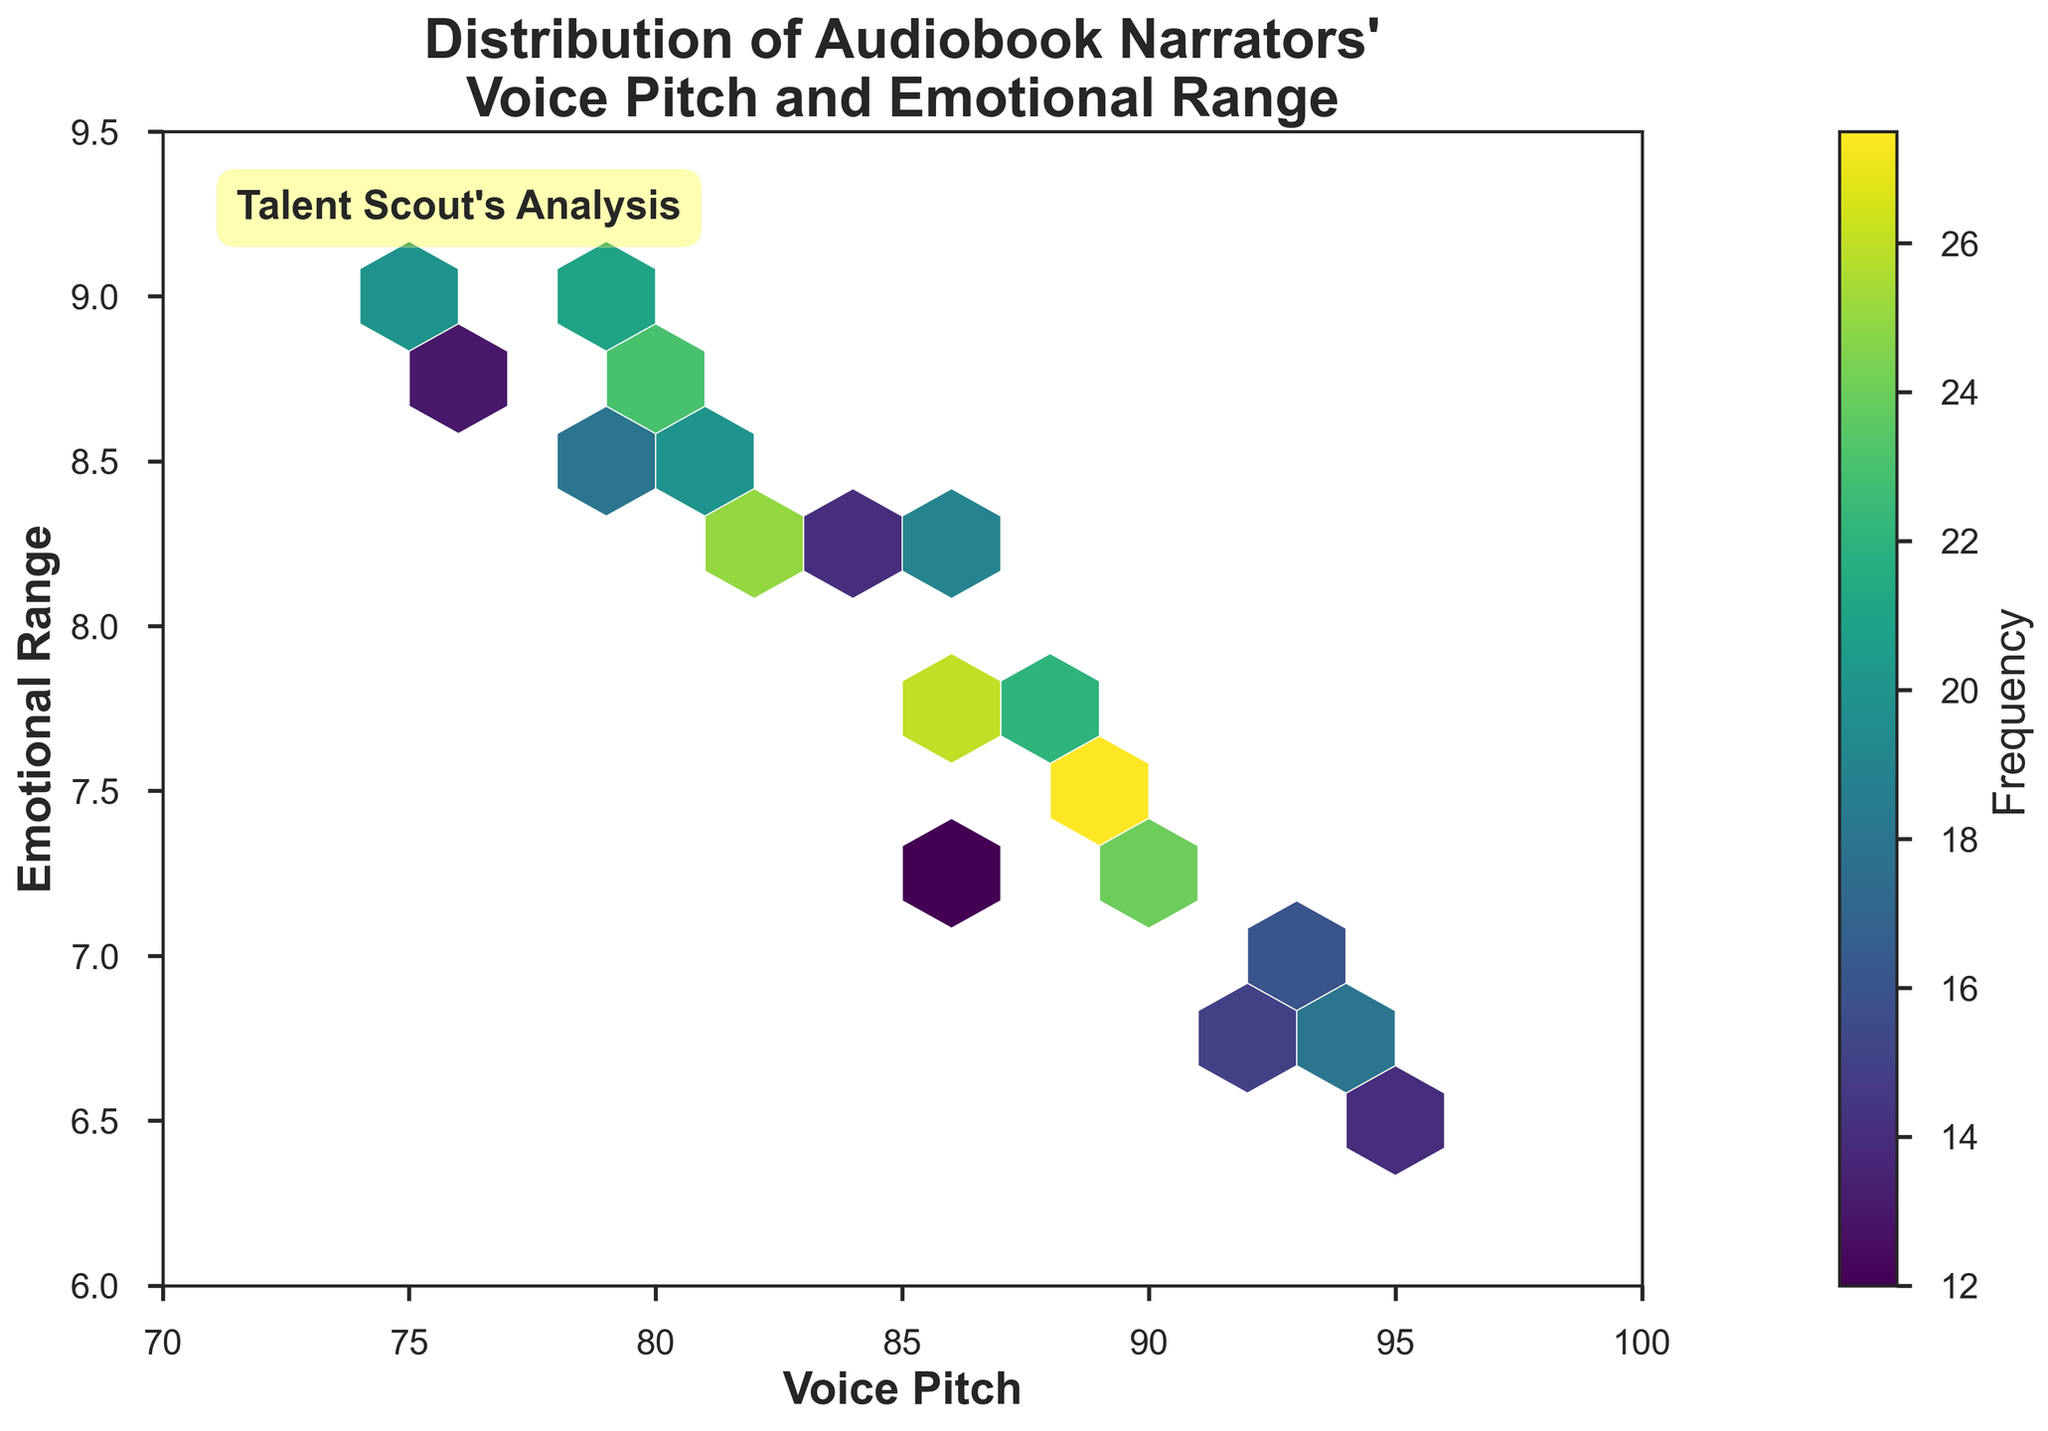What is the title of the figure? The title is written at the top center of the chart. It reads "Distribution of Audiobook Narrators' Voice Pitch and Emotional Range."
Answer: Distribution of Audiobook Narrators' Voice Pitch and Emotional Range What are the labels for the x-axis and y-axis? The x-axis label is shown beneath the horizontal axis as "Voice Pitch," and the y-axis label is alongside the vertical axis as "Emotional Range."
Answer: Voice Pitch, Emotional Range What is the color scheme used for the hexbin plot? The hexbin plot uses a color scheme that transitions from lighter to darker shades of purple to yellow, indicating variations in frequency.
Answer: Viridis Which frequency has the darkest color in the hexbin plot? The darkest color is representative of the highest frequency in the data. By referring to the colorbar, the darkest shade corresponds to a frequency around 28.
Answer: 28 Where do the highest frequencies occur in relation to voice pitch and emotional range? The highest frequencies are represented by darker hexagons, which appear around a voice pitch of 90 and an emotional range of approximately 7.5.
Answer: Voice pitch ~90, Emotional range ~7.5 What is the range of data values for voice pitch shown on the x-axis? The x-axis spans from 70 to 100, as indicated by the limits set on the plot.
Answer: 70 to 100 What is the range of data values for emotional range shown on the y-axis? The y-axis spans from 6 to 9.5, as indicated by the limits set on the plot.
Answer: 6 to 9.5 What is the average value of the highest density areas for voice pitch and emotional range? The highest density areas are centered around specific values visible from the darkest hexbin regions. Averaging the central voice pitch (~90) and emotional range (~7.5) gives values around 90 and 7.5 respectively.
Answer: Voice pitch ~90, Emotional range ~7.5 How many distinct frequency hexagons can be observed in the figure? Distinct frequency hexagons are represented by varying color shades, which can be counted by tracing through the figure.
Answer: Multiple (specific count requires visual inspection) What is the relationship between voice pitch and emotional range with respect to frequency? Higher frequencies appear where voice pitch and emotional range are moderate (around 85-95 for pitch and 7-8 for range), indicating a possible clustering of narrators' capabilities in these ranges.
Answer: Clustered around moderate values 